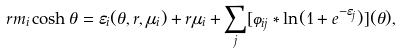Convert formula to latex. <formula><loc_0><loc_0><loc_500><loc_500>r m _ { i } \cosh \theta = \varepsilon _ { i } ( \theta , r , \mu _ { i } ) + r \mu _ { i } + \sum _ { j } [ \varphi _ { i j } \ast \ln ( 1 + e ^ { - \varepsilon _ { j } } ) ] ( \theta ) ,</formula> 